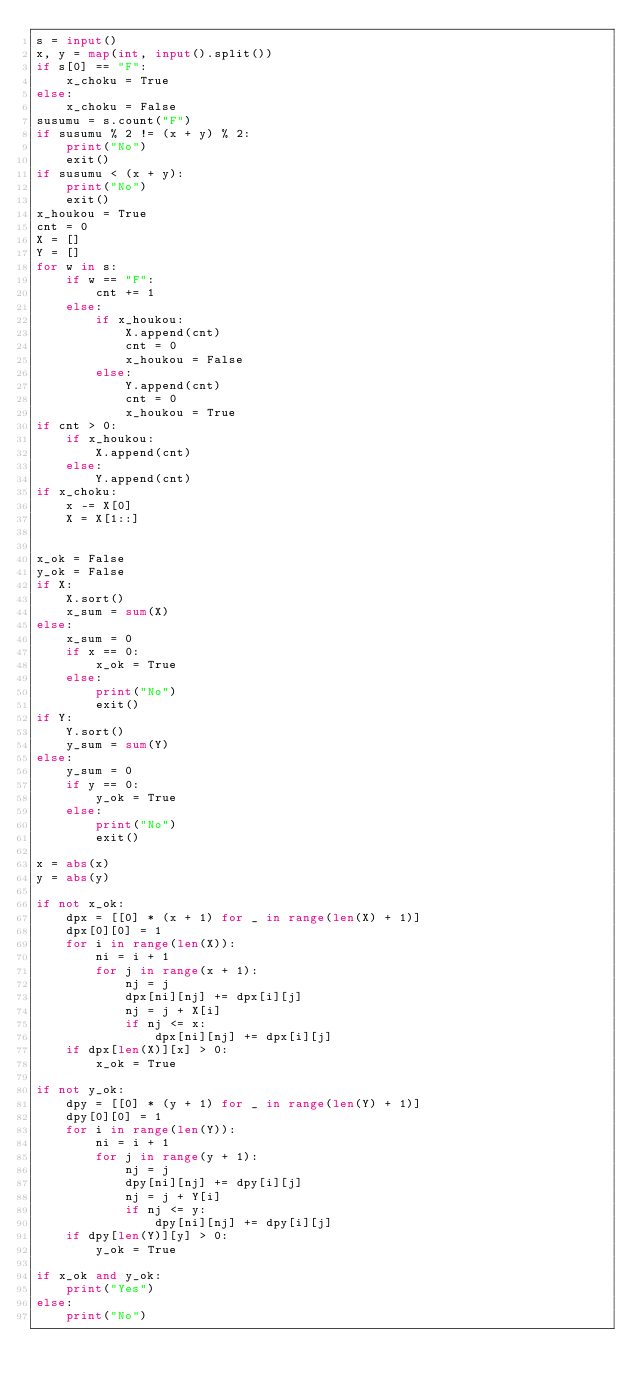<code> <loc_0><loc_0><loc_500><loc_500><_Python_>s = input()
x, y = map(int, input().split())
if s[0] == "F":
    x_choku = True
else:
    x_choku = False
susumu = s.count("F")
if susumu % 2 != (x + y) % 2:
    print("No")
    exit()
if susumu < (x + y):
    print("No")
    exit()
x_houkou = True
cnt = 0
X = []
Y = []
for w in s:
    if w == "F":
        cnt += 1
    else:
        if x_houkou:
            X.append(cnt)
            cnt = 0
            x_houkou = False
        else:
            Y.append(cnt)
            cnt = 0
            x_houkou = True
if cnt > 0:
    if x_houkou:
        X.append(cnt)
    else:
        Y.append(cnt)
if x_choku:
    x -= X[0]
    X = X[1::]


x_ok = False
y_ok = False
if X:
    X.sort()
    x_sum = sum(X)
else:
    x_sum = 0
    if x == 0:
        x_ok = True
    else:
        print("No")
        exit()
if Y:
    Y.sort()
    y_sum = sum(Y)
else:
    y_sum = 0
    if y == 0:
        y_ok = True
    else:
        print("No")
        exit()

x = abs(x)
y = abs(y)

if not x_ok:
    dpx = [[0] * (x + 1) for _ in range(len(X) + 1)]
    dpx[0][0] = 1
    for i in range(len(X)):
        ni = i + 1
        for j in range(x + 1):
            nj = j
            dpx[ni][nj] += dpx[i][j]
            nj = j + X[i]
            if nj <= x:
                dpx[ni][nj] += dpx[i][j]
    if dpx[len(X)][x] > 0:
        x_ok = True

if not y_ok:
    dpy = [[0] * (y + 1) for _ in range(len(Y) + 1)]
    dpy[0][0] = 1
    for i in range(len(Y)):
        ni = i + 1
        for j in range(y + 1):
            nj = j
            dpy[ni][nj] += dpy[i][j]
            nj = j + Y[i]
            if nj <= y:
                dpy[ni][nj] += dpy[i][j]
    if dpy[len(Y)][y] > 0:
        y_ok = True

if x_ok and y_ok:
    print("Yes")
else:
    print("No")
</code> 